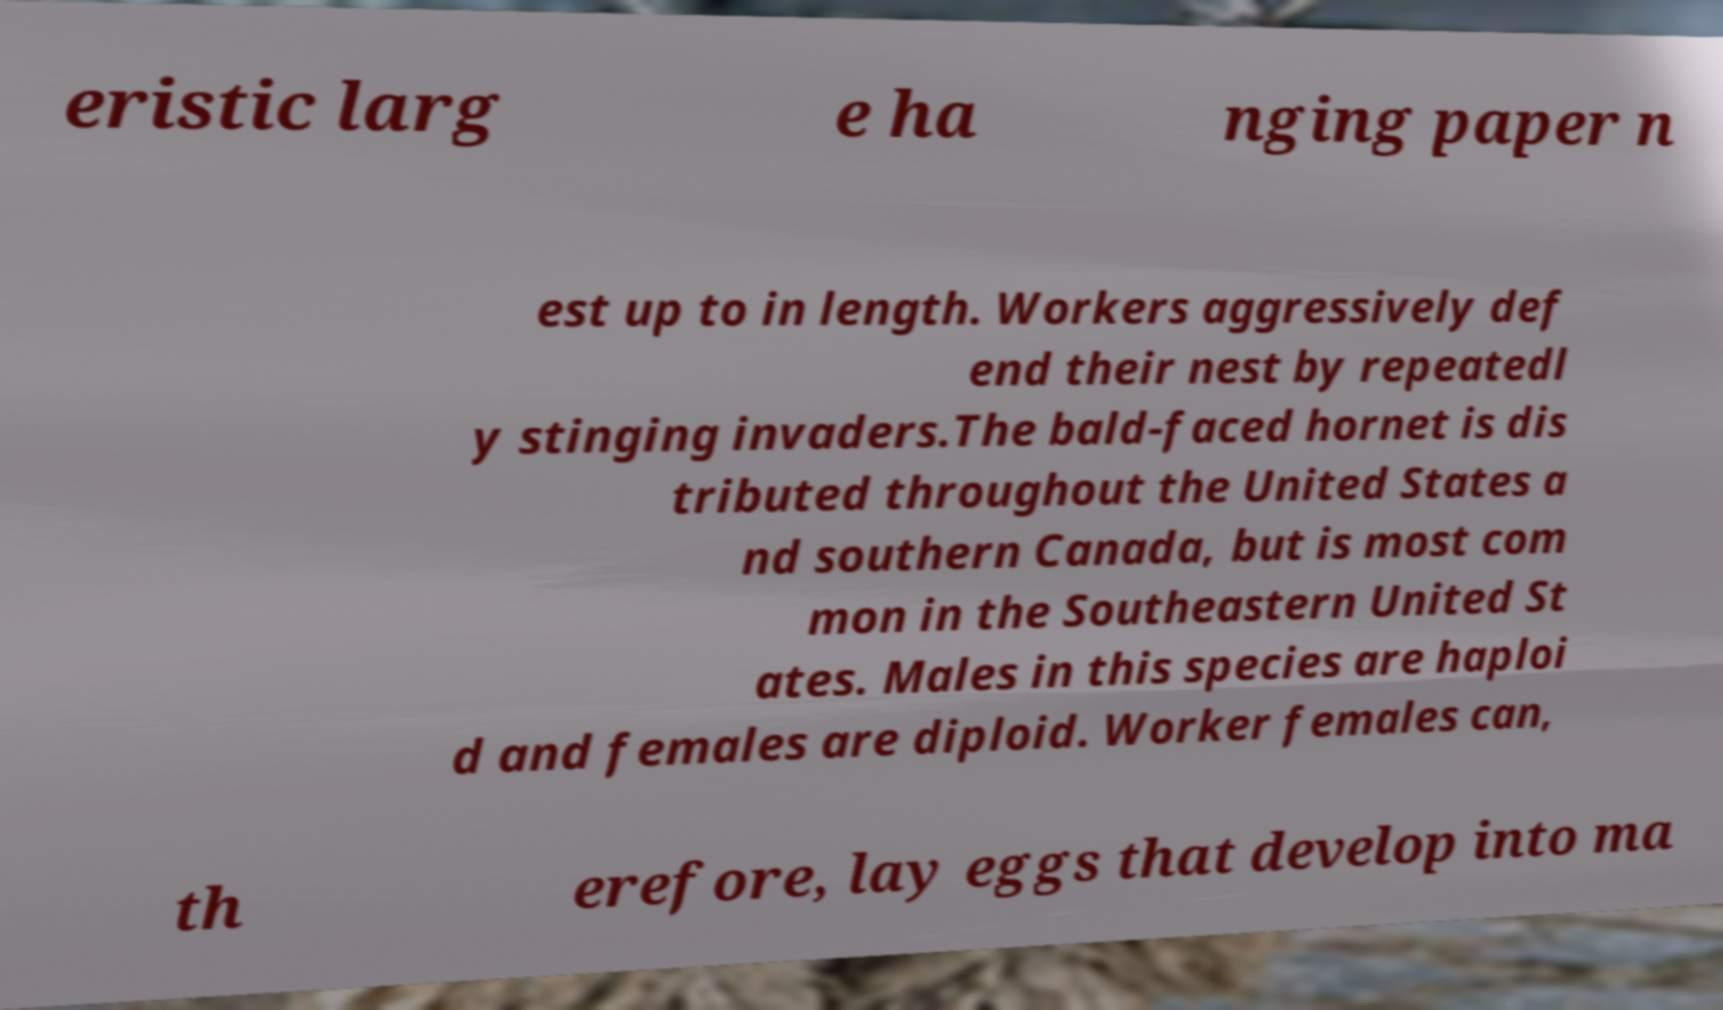Can you read and provide the text displayed in the image?This photo seems to have some interesting text. Can you extract and type it out for me? eristic larg e ha nging paper n est up to in length. Workers aggressively def end their nest by repeatedl y stinging invaders.The bald-faced hornet is dis tributed throughout the United States a nd southern Canada, but is most com mon in the Southeastern United St ates. Males in this species are haploi d and females are diploid. Worker females can, th erefore, lay eggs that develop into ma 